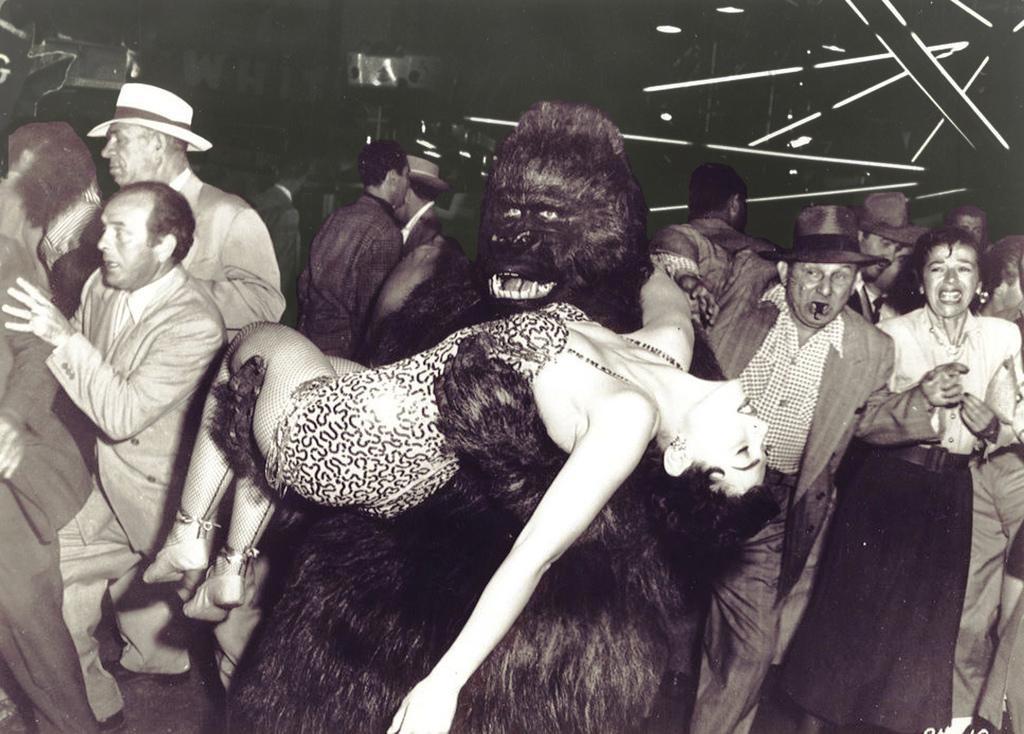How would you summarize this image in a sentence or two? In this image I can see the group of people with dresses and few people with hats. I can see one person in an animal costume and the person is carrying another person. And this is an old image. 